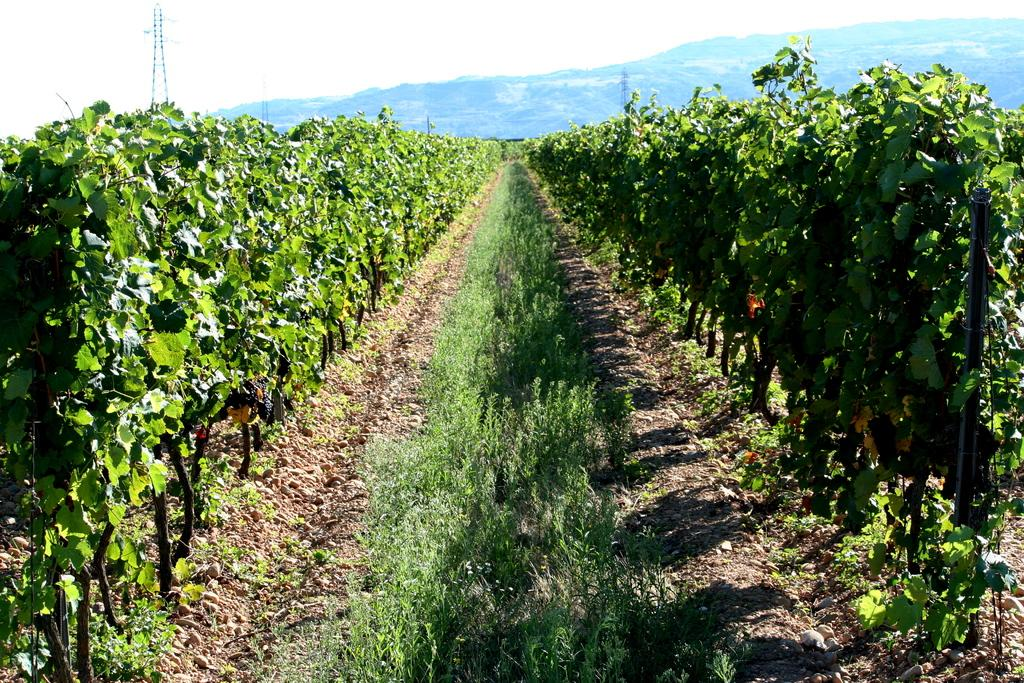What type of vegetation is in the middle of the path in the image? There is grass in the middle of the path in the image. What else can be seen on either side of the path? There are plants on either side of the path. What geographical feature is visible in the background of the image? There is a mountain visible in the background of the image. What part of the natural environment is visible above the mountain? The sky is visible above the mountain. Can you tell me how many times the locket is turned in the image? There is no locket present in the image, so it cannot be turned. Who has control over the mountain in the image? The image is a photograph, and therefore, no one has control over the mountain in the image. 